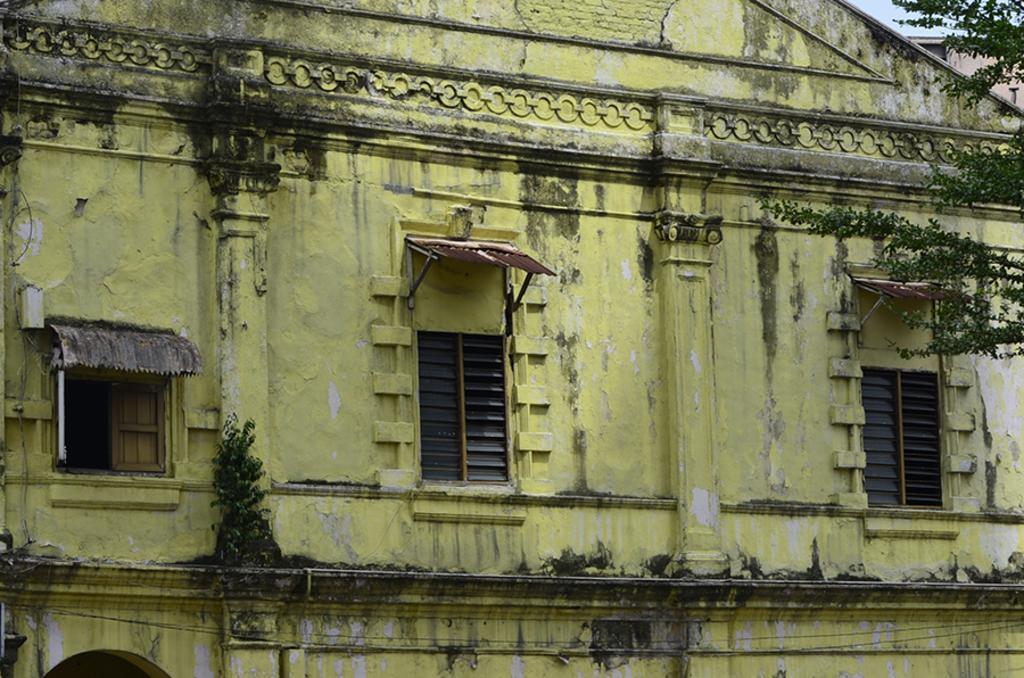How would you summarize this image in a sentence or two? In this image we can see a building with windows. We can also see some branches of a tree, plants and the sky. 